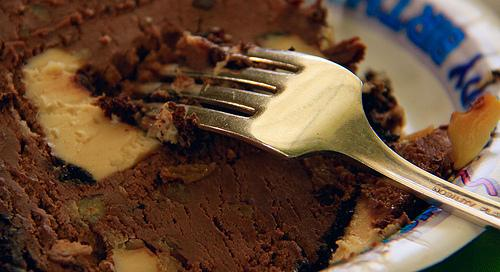Evaluate the overall quality of the image based on the given information. The overall image quality is good, considering the visualization of various elements like chocolate cheese cake, paper bowl, fork, and plate with detailed descriptions. Mention the type of plate used in the image and list some specific details about its design. A white paper plate with blue writing on the edge is used, featuring the letters 'r', 'b', 'y', and 'p'. In the image, describe any unreadable or obscured elements. There is small unreadable writing on the back of the silver fork's handle and electric blue writing on the side of a white plate. Analyze the sentiment of the image based on the objects contained. The sentiment of the image is positive and celebratory, as it depicts a delicious chocolate cheese cake in a birthday-themed paper bowl. Based on the image information, provide a potential reason for using a fork instead of a spoon for this dessert. The use of a fork could be due to the cake's consistency and texture, which might be firmer than a typical ice cream or soft dessert, making it easier to eat with a fork. Recall the image's components that portray the cake's various parts and colors. The components include chocolate frosting with vanilla inside, brown colored frosting, light colored part of the cake, and dark chocolate part of the cake. What kind of dessert is being shown in the image and what specific utensil is being used to eat it? The dessert is chocolate cheese cake in a birthday paper bowl, and it is being eaten with a silver steel fork with four tines on the end. Discuss how the fork is designed and its interaction with the cake. The fork has four silver tines on the bottom, a silver handle, and some engraving on its handle. It is inserted into the cake and has a piece of cake on it. Provide a general description of the cake's condition and the eating implement's position in the image. The cake is partially eaten, and an upside-down fork with chocolate cake on it is sticking out of the dessert. Count the number of objects interacting with the chocolate cheese cake. Two objects are interacting with the chocolate cheese cake - a fork and a paper bowl. Is the chocolate ice cream in a clear glass bowl instead of a paper bowl? No, it's not mentioned in the image. Are there red and blue letters on the edge of the paper bowl? There is no mention of red letters on the edge of the paper bowl, only blue and white letters. 